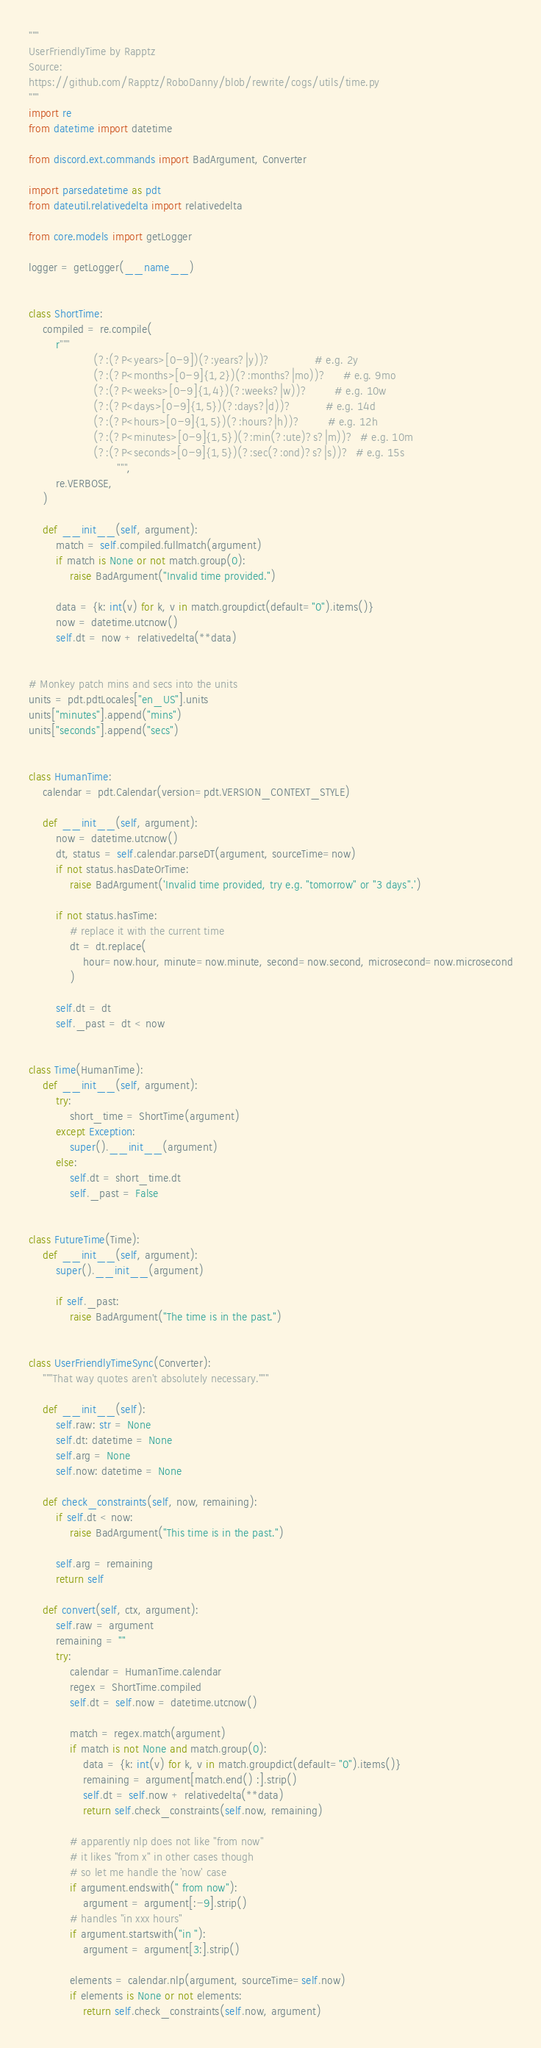Convert code to text. <code><loc_0><loc_0><loc_500><loc_500><_Python_>"""
UserFriendlyTime by Rapptz
Source:
https://github.com/Rapptz/RoboDanny/blob/rewrite/cogs/utils/time.py
"""
import re
from datetime import datetime

from discord.ext.commands import BadArgument, Converter

import parsedatetime as pdt
from dateutil.relativedelta import relativedelta

from core.models import getLogger

logger = getLogger(__name__)


class ShortTime:
    compiled = re.compile(
        r"""
                   (?:(?P<years>[0-9])(?:years?|y))?             # e.g. 2y
                   (?:(?P<months>[0-9]{1,2})(?:months?|mo))?     # e.g. 9mo
                   (?:(?P<weeks>[0-9]{1,4})(?:weeks?|w))?        # e.g. 10w
                   (?:(?P<days>[0-9]{1,5})(?:days?|d))?          # e.g. 14d
                   (?:(?P<hours>[0-9]{1,5})(?:hours?|h))?        # e.g. 12h
                   (?:(?P<minutes>[0-9]{1,5})(?:min(?:ute)?s?|m))?  # e.g. 10m
                   (?:(?P<seconds>[0-9]{1,5})(?:sec(?:ond)?s?|s))?  # e.g. 15s
                          """,
        re.VERBOSE,
    )

    def __init__(self, argument):
        match = self.compiled.fullmatch(argument)
        if match is None or not match.group(0):
            raise BadArgument("Invalid time provided.")

        data = {k: int(v) for k, v in match.groupdict(default="0").items()}
        now = datetime.utcnow()
        self.dt = now + relativedelta(**data)


# Monkey patch mins and secs into the units
units = pdt.pdtLocales["en_US"].units
units["minutes"].append("mins")
units["seconds"].append("secs")


class HumanTime:
    calendar = pdt.Calendar(version=pdt.VERSION_CONTEXT_STYLE)

    def __init__(self, argument):
        now = datetime.utcnow()
        dt, status = self.calendar.parseDT(argument, sourceTime=now)
        if not status.hasDateOrTime:
            raise BadArgument('Invalid time provided, try e.g. "tomorrow" or "3 days".')

        if not status.hasTime:
            # replace it with the current time
            dt = dt.replace(
                hour=now.hour, minute=now.minute, second=now.second, microsecond=now.microsecond
            )

        self.dt = dt
        self._past = dt < now


class Time(HumanTime):
    def __init__(self, argument):
        try:
            short_time = ShortTime(argument)
        except Exception:
            super().__init__(argument)
        else:
            self.dt = short_time.dt
            self._past = False


class FutureTime(Time):
    def __init__(self, argument):
        super().__init__(argument)

        if self._past:
            raise BadArgument("The time is in the past.")


class UserFriendlyTimeSync(Converter):
    """That way quotes aren't absolutely necessary."""

    def __init__(self):
        self.raw: str = None
        self.dt: datetime = None
        self.arg = None
        self.now: datetime = None

    def check_constraints(self, now, remaining):
        if self.dt < now:
            raise BadArgument("This time is in the past.")

        self.arg = remaining
        return self

    def convert(self, ctx, argument):
        self.raw = argument
        remaining = ""
        try:
            calendar = HumanTime.calendar
            regex = ShortTime.compiled
            self.dt = self.now = datetime.utcnow()

            match = regex.match(argument)
            if match is not None and match.group(0):
                data = {k: int(v) for k, v in match.groupdict(default="0").items()}
                remaining = argument[match.end() :].strip()
                self.dt = self.now + relativedelta(**data)
                return self.check_constraints(self.now, remaining)

            # apparently nlp does not like "from now"
            # it likes "from x" in other cases though
            # so let me handle the 'now' case
            if argument.endswith(" from now"):
                argument = argument[:-9].strip()
            # handles "in xxx hours"
            if argument.startswith("in "):
                argument = argument[3:].strip()

            elements = calendar.nlp(argument, sourceTime=self.now)
            if elements is None or not elements:
                return self.check_constraints(self.now, argument)
</code> 